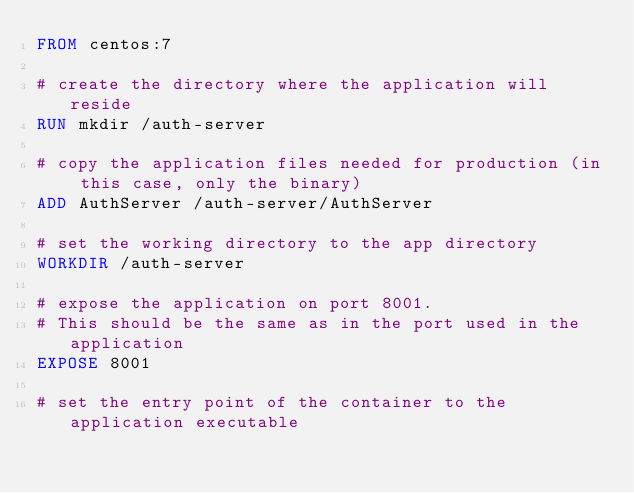<code> <loc_0><loc_0><loc_500><loc_500><_Dockerfile_>FROM centos:7

# create the directory where the application will reside
RUN mkdir /auth-server 

# copy the application files needed for production (in this case, only the binary)
ADD AuthServer /auth-server/AuthServer

# set the working directory to the app directory
WORKDIR /auth-server

# expose the application on port 8001. 
# This should be the same as in the port used in the application
EXPOSE 8001

# set the entry point of the container to the application executable</code> 